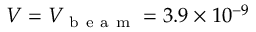Convert formula to latex. <formula><loc_0><loc_0><loc_500><loc_500>V = V _ { b e a m } = 3 . 9 \times 1 0 ^ { - 9 }</formula> 